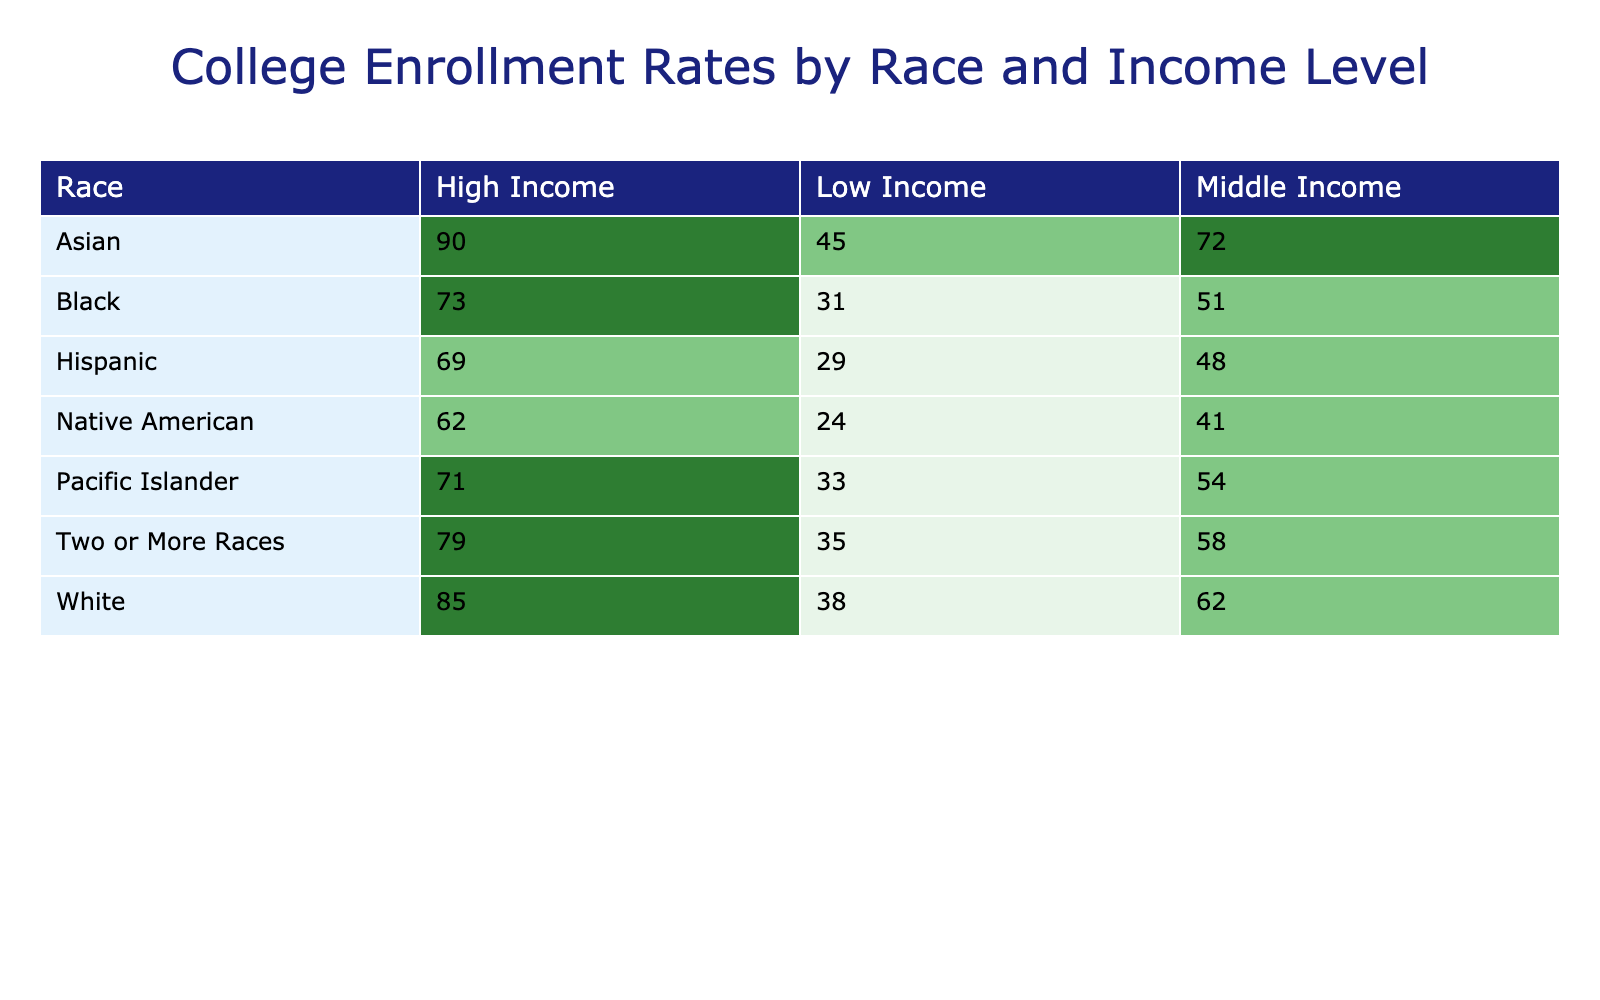What is the college enrollment rate for Black students from low-income families? The table shows that the enrollment rate for Black students in the Low Income category is 31%.
Answer: 31% Which race has the highest college enrollment rate among middle-income students? The table indicates that Asian students have the highest enrollment rate at 72% among the middle-income category.
Answer: Asian What is the difference in enrollment rates between high-income White students and high-income Hispanic students? The enrollment rate for high-income White students is 85%, and for high-income Hispanic students, it is 69%. The difference is 85 - 69 = 16%.
Answer: 16% What is the average college enrollment rate for low-income students across all races? To find the average, add the rates for low-income students: (38 + 31 + 29 + 45 + 24 + 33 + 35) =  265. There are 7 groups, so the average is 265 / 7 = 37.14%.
Answer: 37.14% Is the enrollment rate for Native American students from middle-income families greater than that for White students from low-income families? The enrollment rate for Native American students in the middle-income category is 41%, while for White students in the low-income category, it is 38%. Since 41% is greater than 38%, the statement is true.
Answer: Yes How many races have a college enrollment rate of over 70% for high-income students? The table shows that the races with enrollment rates over 70% for high-income students are White (85%), Black (73%), Hispanic (69%), Asian (90%), and Two or More Races (79%). There are four races that exceed this threshold.
Answer: 4 What is the enrollment rate for Two or More Races students with low income compared to that of Pacific Islander students in the same income category? The enrollment rate for Two or More Races in the low-income category is 35%, while for Pacific Islander students, it is 33%. Since 35% is greater than 33%, Two or More Races students have a higher enrollment rate.
Answer: Yes What is the overall trend for college enrollment rates as income levels increase across different races? Looking at the data, it's evident that for each race, the enrollment rate tends to increase as the income level rises, indicating a positive correlation between income and college enrollment rates.
Answer: Positive correlation 